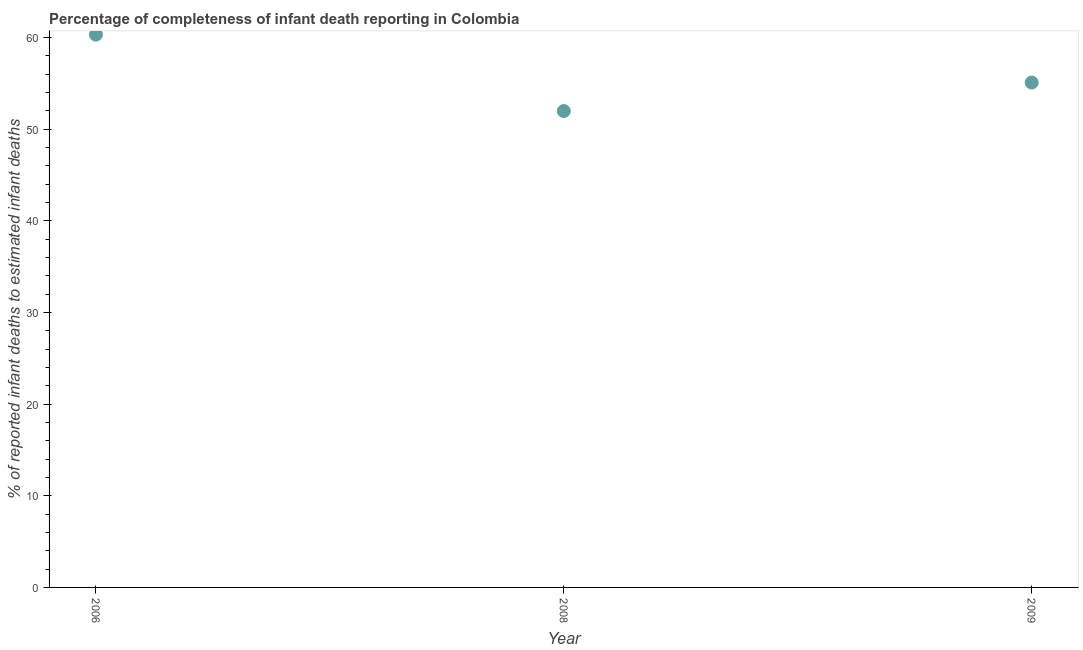What is the completeness of infant death reporting in 2009?
Make the answer very short. 55.07. Across all years, what is the maximum completeness of infant death reporting?
Make the answer very short. 60.29. Across all years, what is the minimum completeness of infant death reporting?
Your answer should be compact. 51.96. In which year was the completeness of infant death reporting minimum?
Keep it short and to the point. 2008. What is the sum of the completeness of infant death reporting?
Keep it short and to the point. 167.32. What is the difference between the completeness of infant death reporting in 2008 and 2009?
Ensure brevity in your answer.  -3.11. What is the average completeness of infant death reporting per year?
Provide a succinct answer. 55.77. What is the median completeness of infant death reporting?
Make the answer very short. 55.07. In how many years, is the completeness of infant death reporting greater than 52 %?
Make the answer very short. 2. What is the ratio of the completeness of infant death reporting in 2008 to that in 2009?
Provide a succinct answer. 0.94. Is the completeness of infant death reporting in 2006 less than that in 2008?
Offer a terse response. No. Is the difference between the completeness of infant death reporting in 2006 and 2009 greater than the difference between any two years?
Offer a very short reply. No. What is the difference between the highest and the second highest completeness of infant death reporting?
Your answer should be very brief. 5.22. Is the sum of the completeness of infant death reporting in 2006 and 2008 greater than the maximum completeness of infant death reporting across all years?
Your response must be concise. Yes. What is the difference between the highest and the lowest completeness of infant death reporting?
Offer a very short reply. 8.34. Does the completeness of infant death reporting monotonically increase over the years?
Provide a short and direct response. No. How many years are there in the graph?
Provide a short and direct response. 3. Does the graph contain grids?
Offer a very short reply. No. What is the title of the graph?
Your answer should be very brief. Percentage of completeness of infant death reporting in Colombia. What is the label or title of the X-axis?
Your answer should be compact. Year. What is the label or title of the Y-axis?
Provide a short and direct response. % of reported infant deaths to estimated infant deaths. What is the % of reported infant deaths to estimated infant deaths in 2006?
Offer a very short reply. 60.29. What is the % of reported infant deaths to estimated infant deaths in 2008?
Offer a very short reply. 51.96. What is the % of reported infant deaths to estimated infant deaths in 2009?
Provide a short and direct response. 55.07. What is the difference between the % of reported infant deaths to estimated infant deaths in 2006 and 2008?
Offer a terse response. 8.34. What is the difference between the % of reported infant deaths to estimated infant deaths in 2006 and 2009?
Offer a terse response. 5.22. What is the difference between the % of reported infant deaths to estimated infant deaths in 2008 and 2009?
Your answer should be very brief. -3.11. What is the ratio of the % of reported infant deaths to estimated infant deaths in 2006 to that in 2008?
Your response must be concise. 1.16. What is the ratio of the % of reported infant deaths to estimated infant deaths in 2006 to that in 2009?
Give a very brief answer. 1.09. What is the ratio of the % of reported infant deaths to estimated infant deaths in 2008 to that in 2009?
Ensure brevity in your answer.  0.94. 